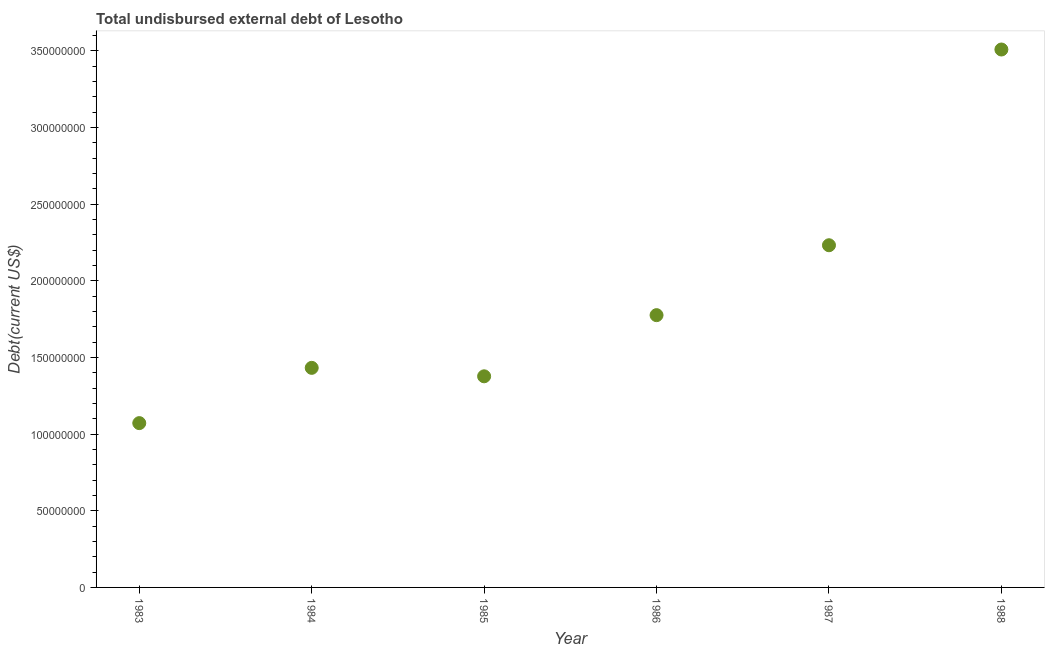What is the total debt in 1987?
Ensure brevity in your answer.  2.23e+08. Across all years, what is the maximum total debt?
Offer a terse response. 3.51e+08. Across all years, what is the minimum total debt?
Ensure brevity in your answer.  1.07e+08. In which year was the total debt minimum?
Provide a succinct answer. 1983. What is the sum of the total debt?
Your answer should be compact. 1.14e+09. What is the difference between the total debt in 1984 and 1985?
Make the answer very short. 5.52e+06. What is the average total debt per year?
Your response must be concise. 1.90e+08. What is the median total debt?
Your answer should be compact. 1.60e+08. In how many years, is the total debt greater than 110000000 US$?
Provide a short and direct response. 5. What is the ratio of the total debt in 1983 to that in 1988?
Give a very brief answer. 0.31. What is the difference between the highest and the second highest total debt?
Ensure brevity in your answer.  1.28e+08. Is the sum of the total debt in 1987 and 1988 greater than the maximum total debt across all years?
Provide a succinct answer. Yes. What is the difference between the highest and the lowest total debt?
Offer a terse response. 2.44e+08. In how many years, is the total debt greater than the average total debt taken over all years?
Offer a very short reply. 2. How many dotlines are there?
Your answer should be compact. 1. How many years are there in the graph?
Offer a very short reply. 6. Are the values on the major ticks of Y-axis written in scientific E-notation?
Keep it short and to the point. No. Does the graph contain grids?
Your answer should be compact. No. What is the title of the graph?
Your response must be concise. Total undisbursed external debt of Lesotho. What is the label or title of the Y-axis?
Make the answer very short. Debt(current US$). What is the Debt(current US$) in 1983?
Provide a short and direct response. 1.07e+08. What is the Debt(current US$) in 1984?
Keep it short and to the point. 1.43e+08. What is the Debt(current US$) in 1985?
Keep it short and to the point. 1.38e+08. What is the Debt(current US$) in 1986?
Make the answer very short. 1.78e+08. What is the Debt(current US$) in 1987?
Keep it short and to the point. 2.23e+08. What is the Debt(current US$) in 1988?
Offer a terse response. 3.51e+08. What is the difference between the Debt(current US$) in 1983 and 1984?
Keep it short and to the point. -3.60e+07. What is the difference between the Debt(current US$) in 1983 and 1985?
Keep it short and to the point. -3.05e+07. What is the difference between the Debt(current US$) in 1983 and 1986?
Offer a terse response. -7.04e+07. What is the difference between the Debt(current US$) in 1983 and 1987?
Provide a short and direct response. -1.16e+08. What is the difference between the Debt(current US$) in 1983 and 1988?
Offer a very short reply. -2.44e+08. What is the difference between the Debt(current US$) in 1984 and 1985?
Keep it short and to the point. 5.52e+06. What is the difference between the Debt(current US$) in 1984 and 1986?
Your response must be concise. -3.44e+07. What is the difference between the Debt(current US$) in 1984 and 1987?
Offer a very short reply. -8.00e+07. What is the difference between the Debt(current US$) in 1984 and 1988?
Give a very brief answer. -2.08e+08. What is the difference between the Debt(current US$) in 1985 and 1986?
Give a very brief answer. -3.99e+07. What is the difference between the Debt(current US$) in 1985 and 1987?
Your answer should be compact. -8.55e+07. What is the difference between the Debt(current US$) in 1985 and 1988?
Offer a terse response. -2.13e+08. What is the difference between the Debt(current US$) in 1986 and 1987?
Provide a short and direct response. -4.56e+07. What is the difference between the Debt(current US$) in 1986 and 1988?
Offer a terse response. -1.73e+08. What is the difference between the Debt(current US$) in 1987 and 1988?
Provide a succinct answer. -1.28e+08. What is the ratio of the Debt(current US$) in 1983 to that in 1984?
Offer a terse response. 0.75. What is the ratio of the Debt(current US$) in 1983 to that in 1985?
Keep it short and to the point. 0.78. What is the ratio of the Debt(current US$) in 1983 to that in 1986?
Give a very brief answer. 0.6. What is the ratio of the Debt(current US$) in 1983 to that in 1987?
Give a very brief answer. 0.48. What is the ratio of the Debt(current US$) in 1983 to that in 1988?
Your answer should be very brief. 0.3. What is the ratio of the Debt(current US$) in 1984 to that in 1985?
Offer a terse response. 1.04. What is the ratio of the Debt(current US$) in 1984 to that in 1986?
Provide a short and direct response. 0.81. What is the ratio of the Debt(current US$) in 1984 to that in 1987?
Your answer should be compact. 0.64. What is the ratio of the Debt(current US$) in 1984 to that in 1988?
Your answer should be very brief. 0.41. What is the ratio of the Debt(current US$) in 1985 to that in 1986?
Your response must be concise. 0.78. What is the ratio of the Debt(current US$) in 1985 to that in 1987?
Keep it short and to the point. 0.62. What is the ratio of the Debt(current US$) in 1985 to that in 1988?
Make the answer very short. 0.39. What is the ratio of the Debt(current US$) in 1986 to that in 1987?
Make the answer very short. 0.8. What is the ratio of the Debt(current US$) in 1986 to that in 1988?
Provide a succinct answer. 0.51. What is the ratio of the Debt(current US$) in 1987 to that in 1988?
Make the answer very short. 0.64. 